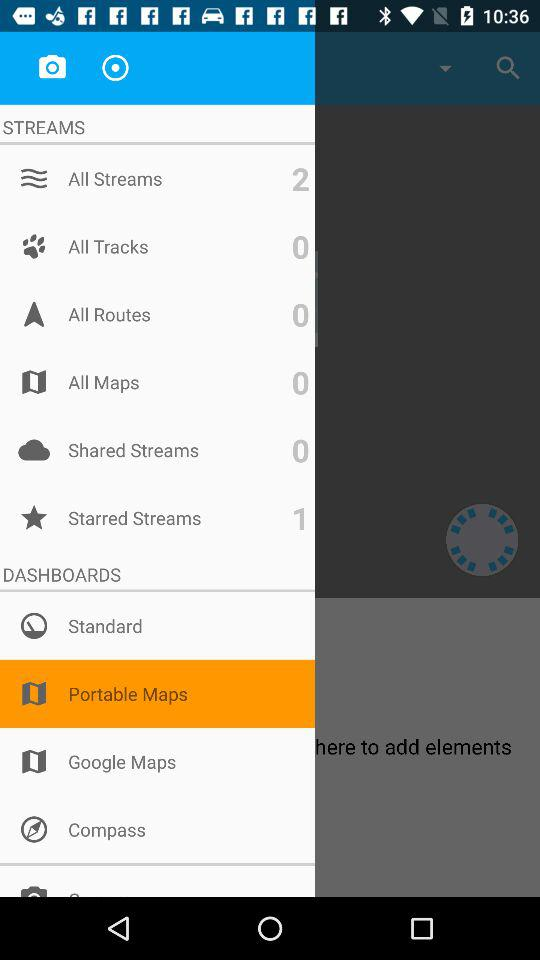How many routes in total are there? There are 0 routes in total. 